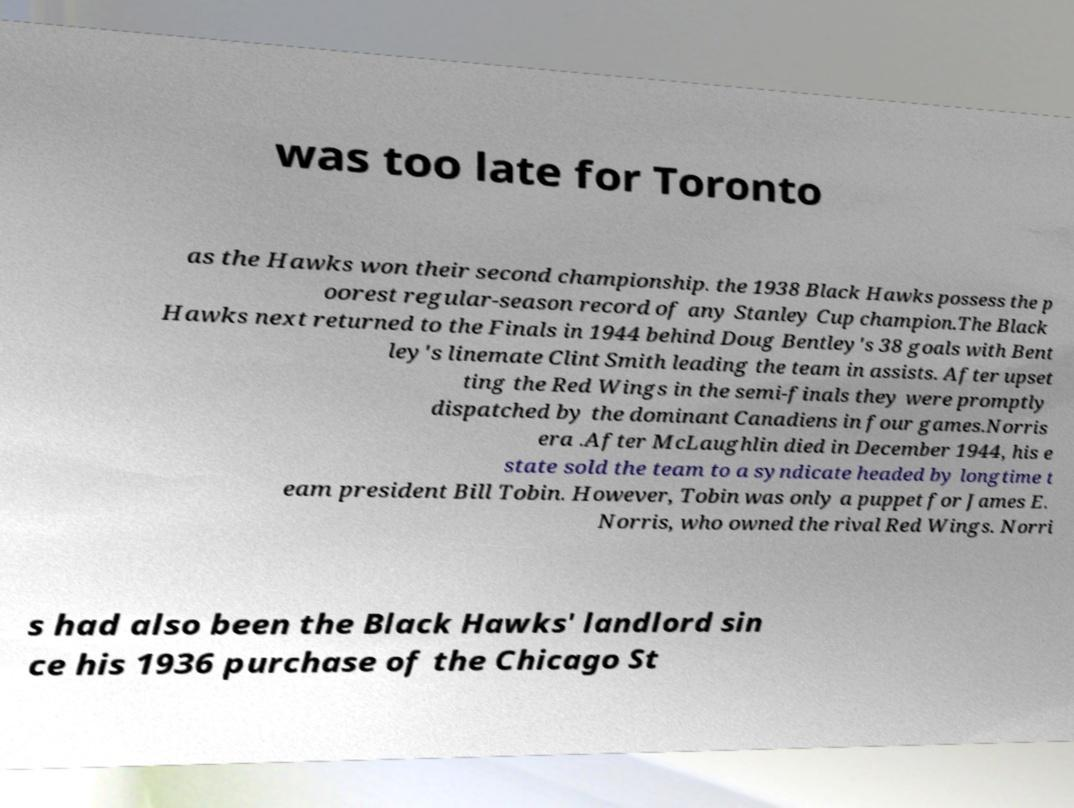Please identify and transcribe the text found in this image. was too late for Toronto as the Hawks won their second championship. the 1938 Black Hawks possess the p oorest regular-season record of any Stanley Cup champion.The Black Hawks next returned to the Finals in 1944 behind Doug Bentley's 38 goals with Bent ley's linemate Clint Smith leading the team in assists. After upset ting the Red Wings in the semi-finals they were promptly dispatched by the dominant Canadiens in four games.Norris era .After McLaughlin died in December 1944, his e state sold the team to a syndicate headed by longtime t eam president Bill Tobin. However, Tobin was only a puppet for James E. Norris, who owned the rival Red Wings. Norri s had also been the Black Hawks' landlord sin ce his 1936 purchase of the Chicago St 